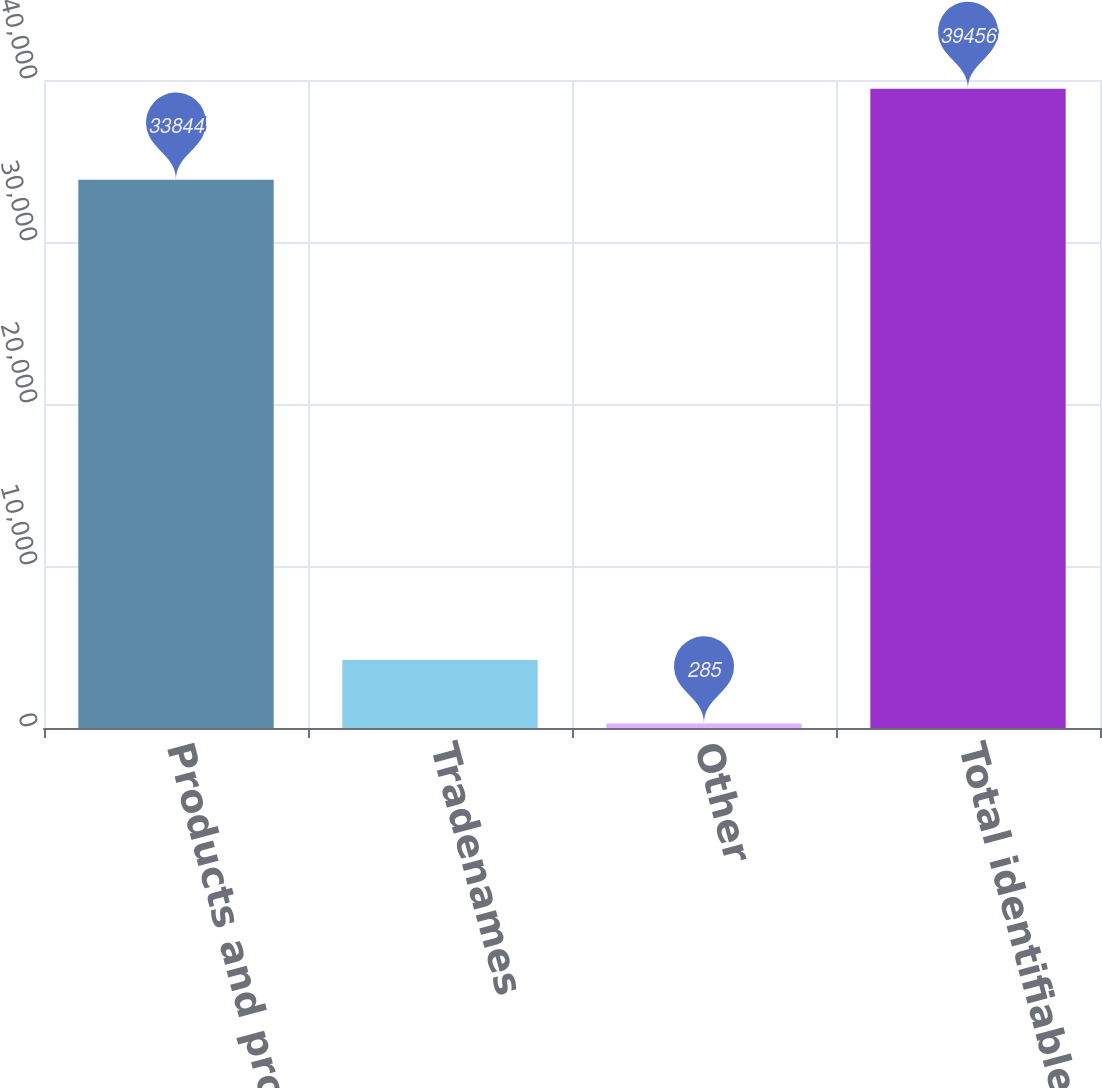Convert chart to OTSL. <chart><loc_0><loc_0><loc_500><loc_500><bar_chart><fcel>Products and product rights<fcel>Tradenames<fcel>Other<fcel>Total identifiable intangible<nl><fcel>33844<fcel>4202.1<fcel>285<fcel>39456<nl></chart> 